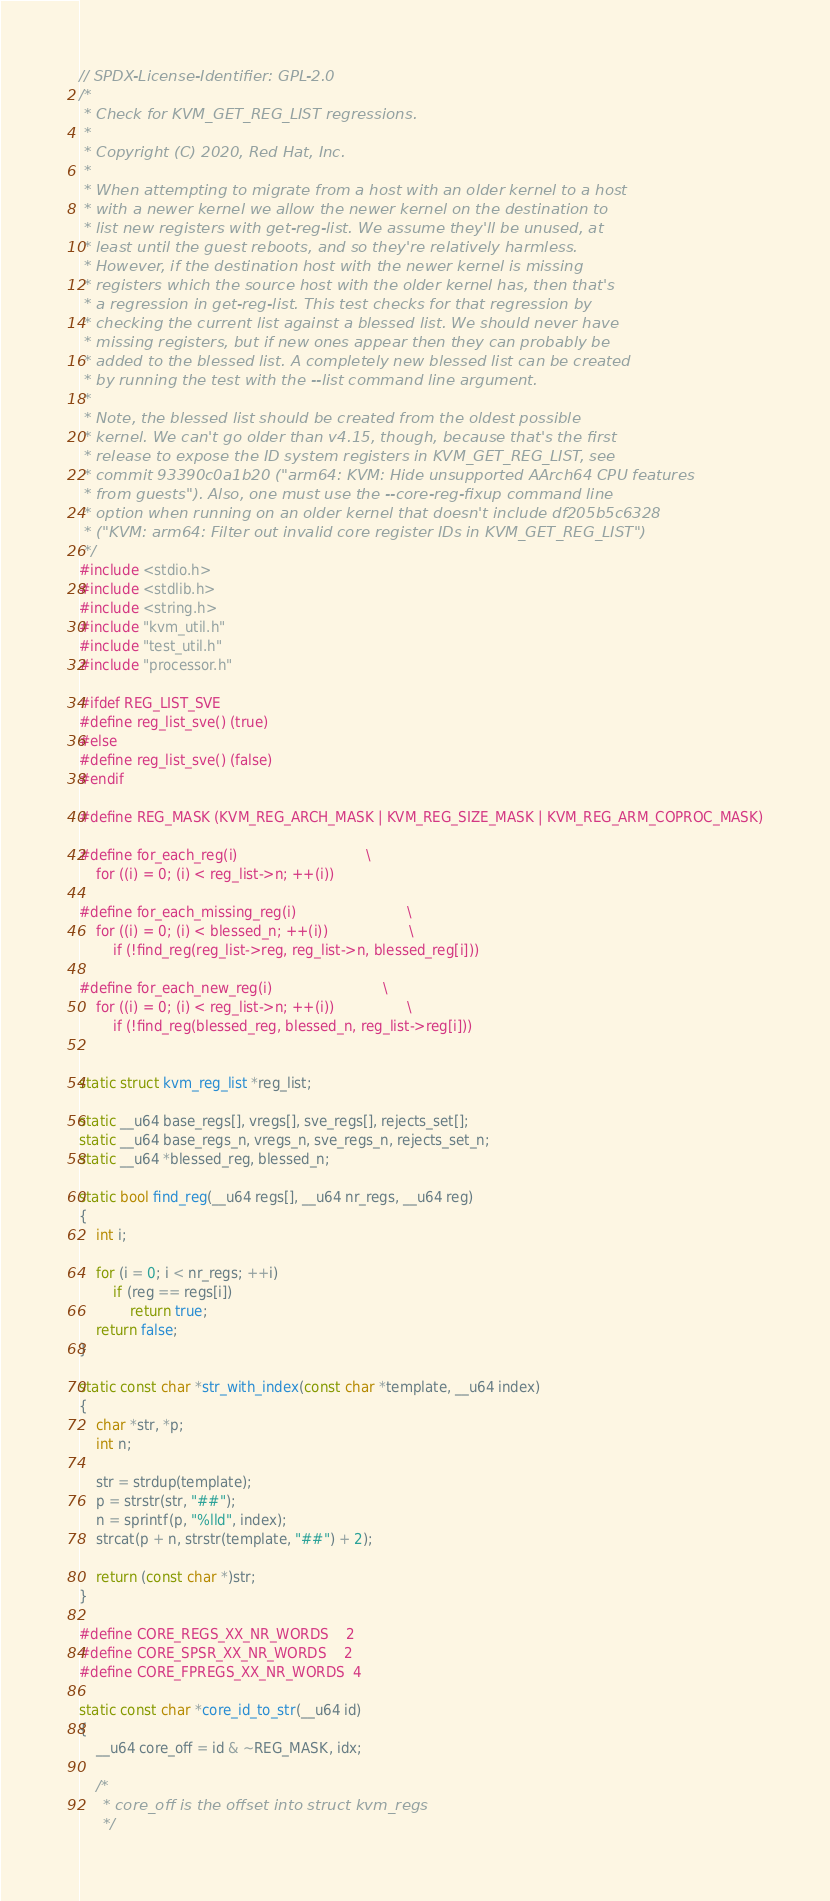Convert code to text. <code><loc_0><loc_0><loc_500><loc_500><_C_>// SPDX-License-Identifier: GPL-2.0
/*
 * Check for KVM_GET_REG_LIST regressions.
 *
 * Copyright (C) 2020, Red Hat, Inc.
 *
 * When attempting to migrate from a host with an older kernel to a host
 * with a newer kernel we allow the newer kernel on the destination to
 * list new registers with get-reg-list. We assume they'll be unused, at
 * least until the guest reboots, and so they're relatively harmless.
 * However, if the destination host with the newer kernel is missing
 * registers which the source host with the older kernel has, then that's
 * a regression in get-reg-list. This test checks for that regression by
 * checking the current list against a blessed list. We should never have
 * missing registers, but if new ones appear then they can probably be
 * added to the blessed list. A completely new blessed list can be created
 * by running the test with the --list command line argument.
 *
 * Note, the blessed list should be created from the oldest possible
 * kernel. We can't go older than v4.15, though, because that's the first
 * release to expose the ID system registers in KVM_GET_REG_LIST, see
 * commit 93390c0a1b20 ("arm64: KVM: Hide unsupported AArch64 CPU features
 * from guests"). Also, one must use the --core-reg-fixup command line
 * option when running on an older kernel that doesn't include df205b5c6328
 * ("KVM: arm64: Filter out invalid core register IDs in KVM_GET_REG_LIST")
 */
#include <stdio.h>
#include <stdlib.h>
#include <string.h>
#include "kvm_util.h"
#include "test_util.h"
#include "processor.h"

#ifdef REG_LIST_SVE
#define reg_list_sve() (true)
#else
#define reg_list_sve() (false)
#endif

#define REG_MASK (KVM_REG_ARCH_MASK | KVM_REG_SIZE_MASK | KVM_REG_ARM_COPROC_MASK)

#define for_each_reg(i)								\
	for ((i) = 0; (i) < reg_list->n; ++(i))

#define for_each_missing_reg(i)							\
	for ((i) = 0; (i) < blessed_n; ++(i))					\
		if (!find_reg(reg_list->reg, reg_list->n, blessed_reg[i]))

#define for_each_new_reg(i)							\
	for ((i) = 0; (i) < reg_list->n; ++(i))					\
		if (!find_reg(blessed_reg, blessed_n, reg_list->reg[i]))


static struct kvm_reg_list *reg_list;

static __u64 base_regs[], vregs[], sve_regs[], rejects_set[];
static __u64 base_regs_n, vregs_n, sve_regs_n, rejects_set_n;
static __u64 *blessed_reg, blessed_n;

static bool find_reg(__u64 regs[], __u64 nr_regs, __u64 reg)
{
	int i;

	for (i = 0; i < nr_regs; ++i)
		if (reg == regs[i])
			return true;
	return false;
}

static const char *str_with_index(const char *template, __u64 index)
{
	char *str, *p;
	int n;

	str = strdup(template);
	p = strstr(str, "##");
	n = sprintf(p, "%lld", index);
	strcat(p + n, strstr(template, "##") + 2);

	return (const char *)str;
}

#define CORE_REGS_XX_NR_WORDS	2
#define CORE_SPSR_XX_NR_WORDS	2
#define CORE_FPREGS_XX_NR_WORDS	4

static const char *core_id_to_str(__u64 id)
{
	__u64 core_off = id & ~REG_MASK, idx;

	/*
	 * core_off is the offset into struct kvm_regs
	 */</code> 